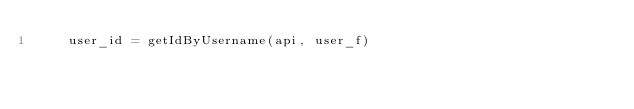<code> <loc_0><loc_0><loc_500><loc_500><_Python_>    user_id = getIdByUsername(api, user_f)
</code> 